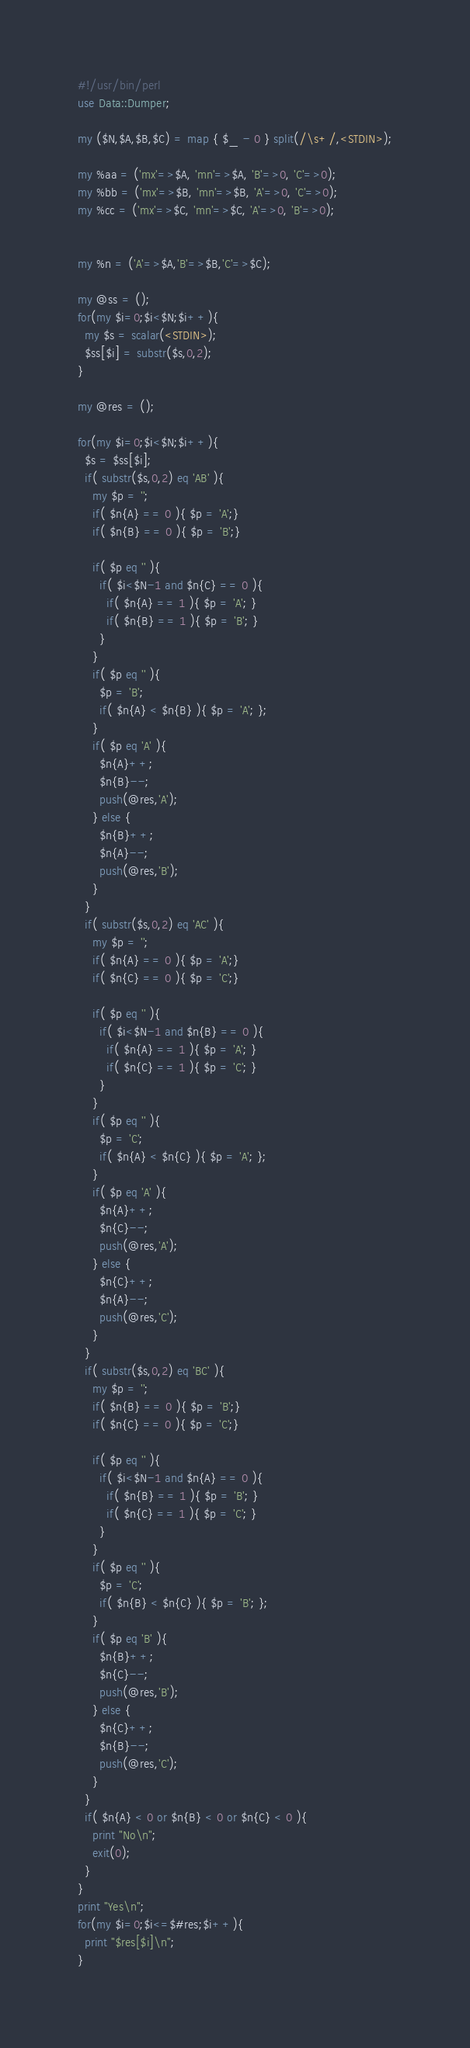<code> <loc_0><loc_0><loc_500><loc_500><_Perl_>#!/usr/bin/perl
use Data::Dumper;

my ($N,$A,$B,$C) = map { $_ - 0 } split(/\s+/,<STDIN>);

my %aa = ('mx'=>$A, 'mn'=>$A, 'B'=>0, 'C'=>0);
my %bb = ('mx'=>$B, 'mn'=>$B, 'A'=>0, 'C'=>0);
my %cc = ('mx'=>$C, 'mn'=>$C, 'A'=>0, 'B'=>0);


my %n = ('A'=>$A,'B'=>$B,'C'=>$C);

my @ss = ();
for(my $i=0;$i<$N;$i++){
  my $s = scalar(<STDIN>);
  $ss[$i] = substr($s,0,2);
}

my @res = ();

for(my $i=0;$i<$N;$i++){
  $s = $ss[$i];
  if( substr($s,0,2) eq 'AB' ){
    my $p = '';
    if( $n{A} == 0 ){ $p = 'A';}
    if( $n{B} == 0 ){ $p = 'B';}
    
    if( $p eq '' ){
      if( $i<$N-1 and $n{C} == 0 ){
        if( $n{A} == 1 ){ $p = 'A'; }
        if( $n{B} == 1 ){ $p = 'B'; }
      }
    }
    if( $p eq '' ){
      $p = 'B';
      if( $n{A} < $n{B} ){ $p = 'A'; };
    }
    if( $p eq 'A' ){
      $n{A}++;
      $n{B}--;
      push(@res,'A');
    } else {
      $n{B}++;
      $n{A}--;
      push(@res,'B');
    }
  }
  if( substr($s,0,2) eq 'AC' ){
    my $p = '';
    if( $n{A} == 0 ){ $p = 'A';}
    if( $n{C} == 0 ){ $p = 'C';}
    
    if( $p eq '' ){
      if( $i<$N-1 and $n{B} == 0 ){
        if( $n{A} == 1 ){ $p = 'A'; }
        if( $n{C} == 1 ){ $p = 'C'; }
      }
    }
    if( $p eq '' ){
      $p = 'C';
      if( $n{A} < $n{C} ){ $p = 'A'; };
    }
    if( $p eq 'A' ){
      $n{A}++;
      $n{C}--;
      push(@res,'A');
    } else {
      $n{C}++;
      $n{A}--;
      push(@res,'C');
    }
  }
  if( substr($s,0,2) eq 'BC' ){
    my $p = '';
    if( $n{B} == 0 ){ $p = 'B';}
    if( $n{C} == 0 ){ $p = 'C';}
    
    if( $p eq '' ){
      if( $i<$N-1 and $n{A} == 0 ){
        if( $n{B} == 1 ){ $p = 'B'; }
        if( $n{C} == 1 ){ $p = 'C'; }
      }
    }
    if( $p eq '' ){
      $p = 'C';
      if( $n{B} < $n{C} ){ $p = 'B'; };
    }
    if( $p eq 'B' ){
      $n{B}++;
      $n{C}--;
      push(@res,'B');
    } else {
      $n{C}++;
      $n{B}--;
      push(@res,'C');
    }
  }
  if( $n{A} < 0 or $n{B} < 0 or $n{C} < 0 ){
    print "No\n";
    exit(0);
  }
}
print "Yes\n";
for(my $i=0;$i<=$#res;$i++){
  print "$res[$i]\n";
}



</code> 